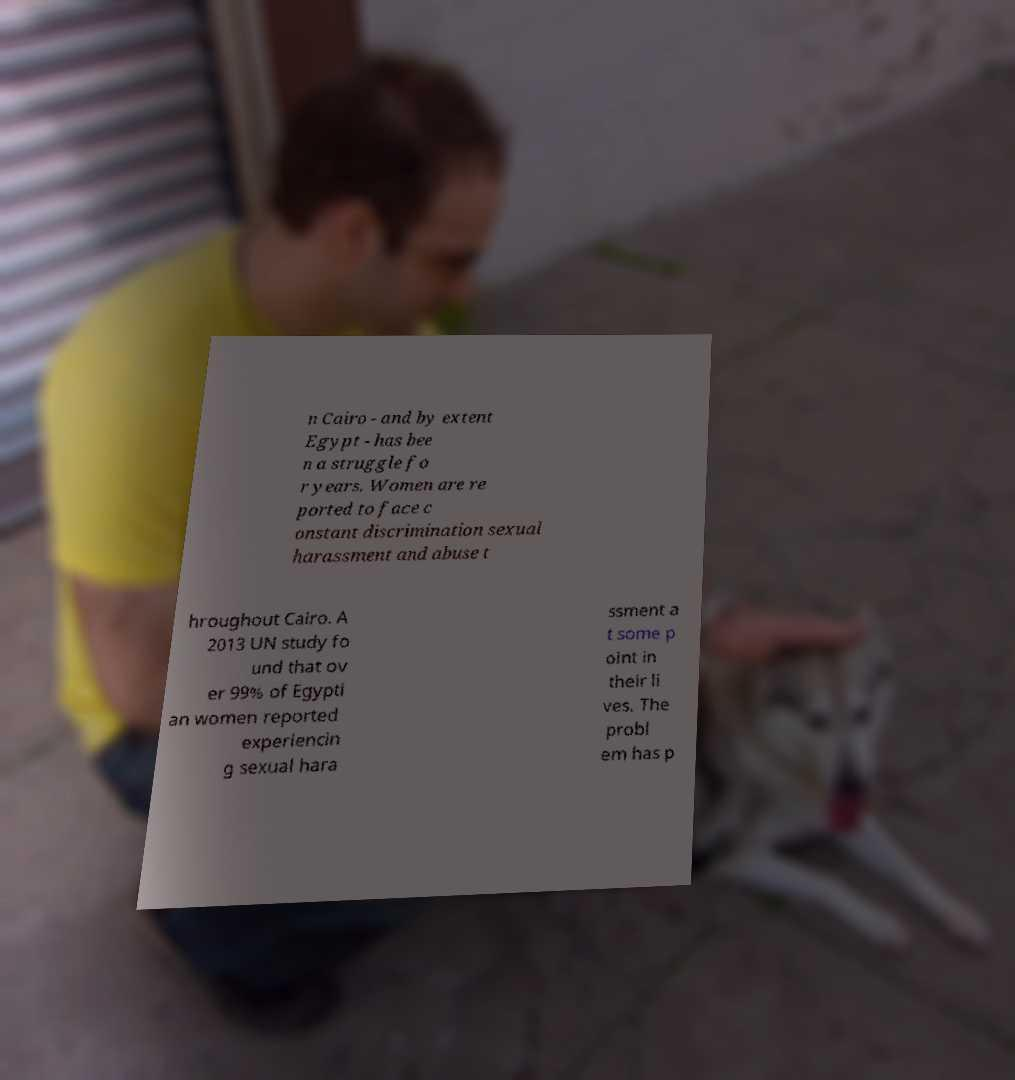Please identify and transcribe the text found in this image. n Cairo - and by extent Egypt - has bee n a struggle fo r years. Women are re ported to face c onstant discrimination sexual harassment and abuse t hroughout Cairo. A 2013 UN study fo und that ov er 99% of Egypti an women reported experiencin g sexual hara ssment a t some p oint in their li ves. The probl em has p 